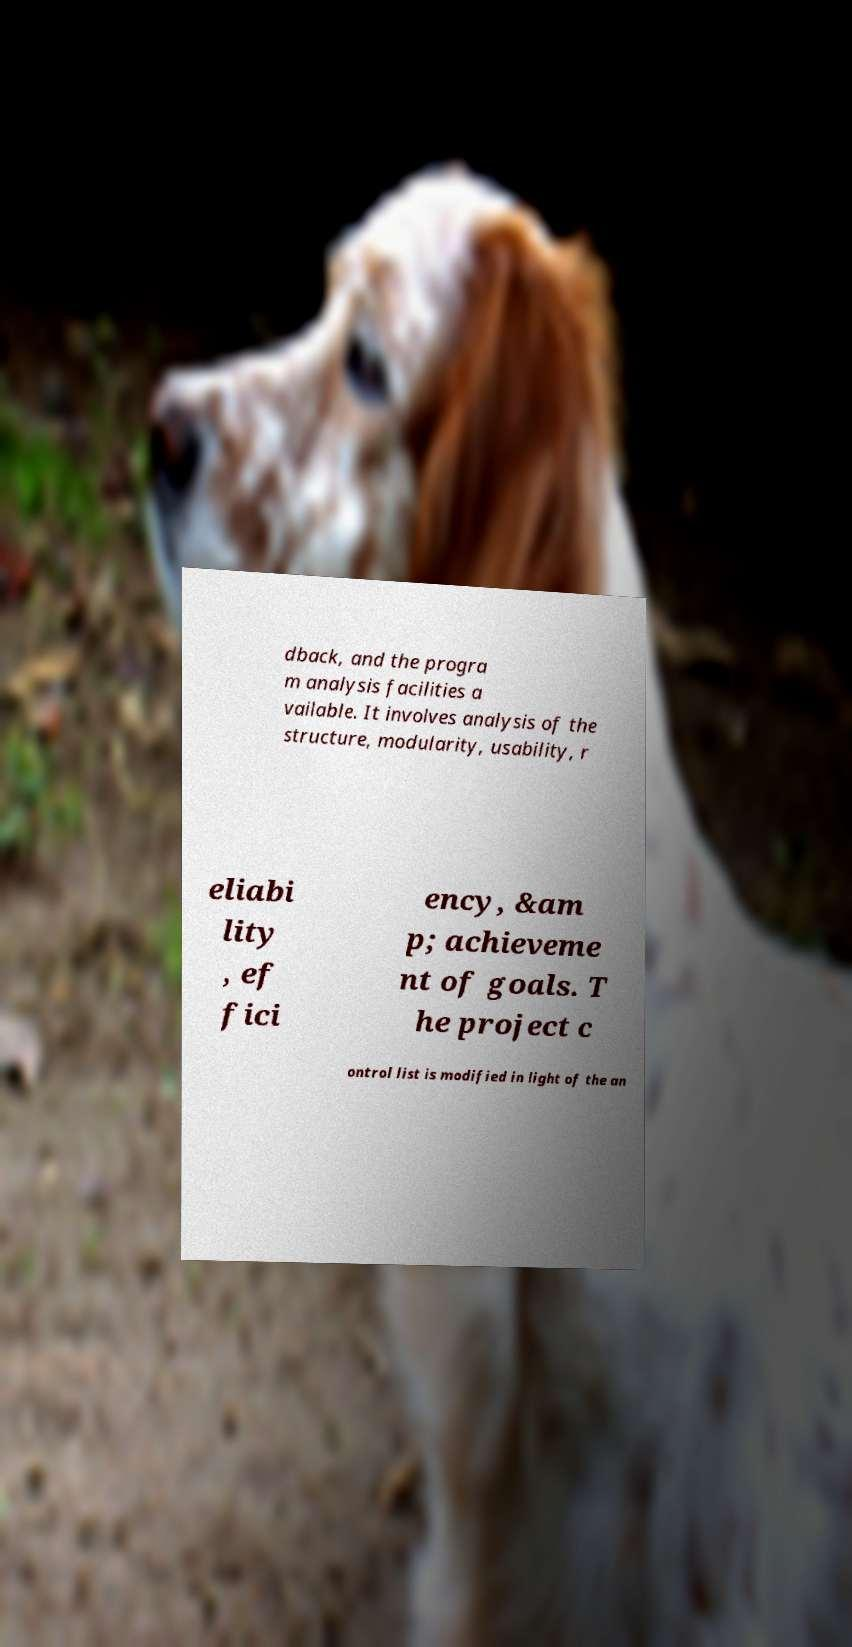I need the written content from this picture converted into text. Can you do that? dback, and the progra m analysis facilities a vailable. It involves analysis of the structure, modularity, usability, r eliabi lity , ef fici ency, &am p; achieveme nt of goals. T he project c ontrol list is modified in light of the an 